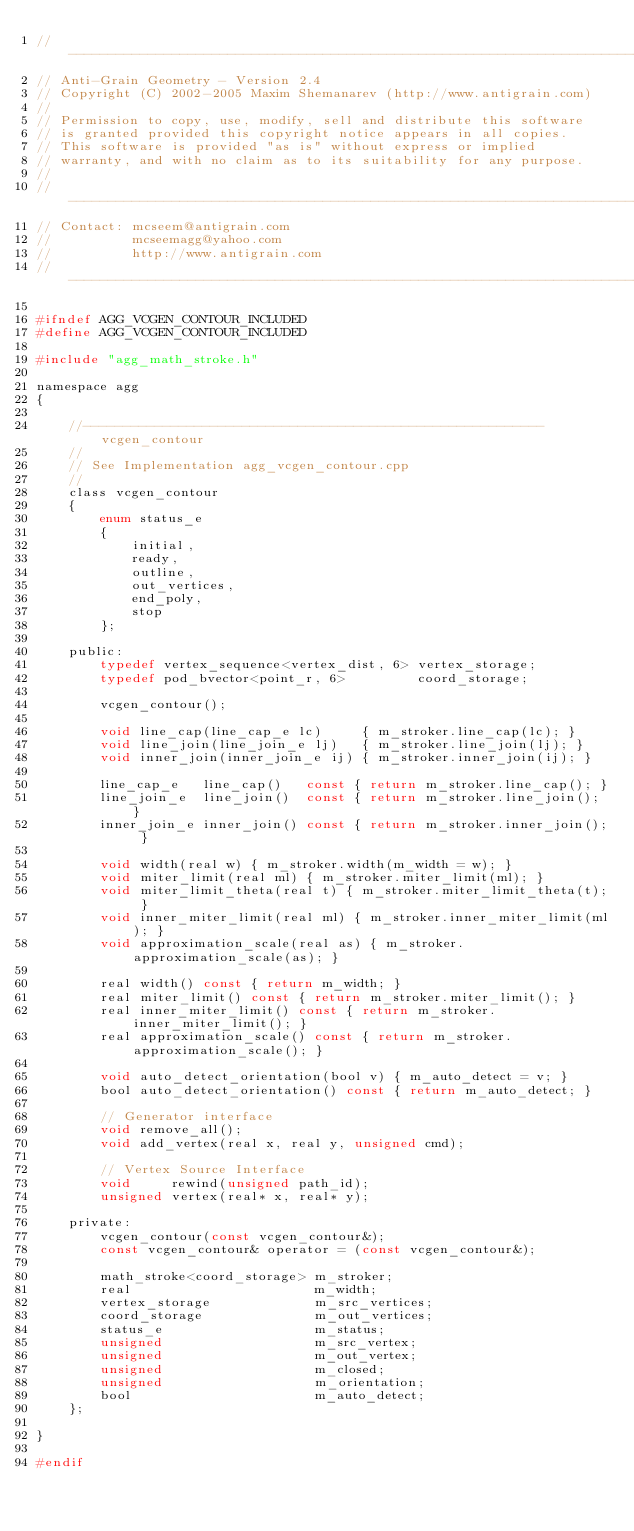Convert code to text. <code><loc_0><loc_0><loc_500><loc_500><_C_>//----------------------------------------------------------------------------
// Anti-Grain Geometry - Version 2.4
// Copyright (C) 2002-2005 Maxim Shemanarev (http://www.antigrain.com)
//
// Permission to copy, use, modify, sell and distribute this software 
// is granted provided this copyright notice appears in all copies. 
// This software is provided "as is" without express or implied
// warranty, and with no claim as to its suitability for any purpose.
//
//----------------------------------------------------------------------------
// Contact: mcseem@antigrain.com
//          mcseemagg@yahoo.com
//          http://www.antigrain.com
//----------------------------------------------------------------------------

#ifndef AGG_VCGEN_CONTOUR_INCLUDED
#define AGG_VCGEN_CONTOUR_INCLUDED

#include "agg_math_stroke.h"

namespace agg
{

    //----------------------------------------------------------vcgen_contour
    //
    // See Implementation agg_vcgen_contour.cpp
    //
    class vcgen_contour
    {
        enum status_e
        {
            initial,
            ready,
            outline,
            out_vertices,
            end_poly,
            stop
        };

    public:
        typedef vertex_sequence<vertex_dist, 6> vertex_storage;
        typedef pod_bvector<point_r, 6>         coord_storage;

        vcgen_contour();

        void line_cap(line_cap_e lc)     { m_stroker.line_cap(lc); }
        void line_join(line_join_e lj)   { m_stroker.line_join(lj); }
        void inner_join(inner_join_e ij) { m_stroker.inner_join(ij); }

        line_cap_e   line_cap()   const { return m_stroker.line_cap(); }
        line_join_e  line_join()  const { return m_stroker.line_join(); }
        inner_join_e inner_join() const { return m_stroker.inner_join(); }

        void width(real w) { m_stroker.width(m_width = w); }
        void miter_limit(real ml) { m_stroker.miter_limit(ml); }
        void miter_limit_theta(real t) { m_stroker.miter_limit_theta(t); }
        void inner_miter_limit(real ml) { m_stroker.inner_miter_limit(ml); }
        void approximation_scale(real as) { m_stroker.approximation_scale(as); }

        real width() const { return m_width; }
        real miter_limit() const { return m_stroker.miter_limit(); }
        real inner_miter_limit() const { return m_stroker.inner_miter_limit(); }
        real approximation_scale() const { return m_stroker.approximation_scale(); }

        void auto_detect_orientation(bool v) { m_auto_detect = v; }
        bool auto_detect_orientation() const { return m_auto_detect; }

        // Generator interface
        void remove_all();
        void add_vertex(real x, real y, unsigned cmd);

        // Vertex Source Interface
        void     rewind(unsigned path_id);
        unsigned vertex(real* x, real* y);

    private:
        vcgen_contour(const vcgen_contour&);
        const vcgen_contour& operator = (const vcgen_contour&);

        math_stroke<coord_storage> m_stroker;
        real                       m_width;
        vertex_storage             m_src_vertices;
        coord_storage              m_out_vertices;
        status_e                   m_status;
        unsigned                   m_src_vertex;
        unsigned                   m_out_vertex;
        unsigned                   m_closed;
        unsigned                   m_orientation;
        bool                       m_auto_detect;
    };

}

#endif
</code> 